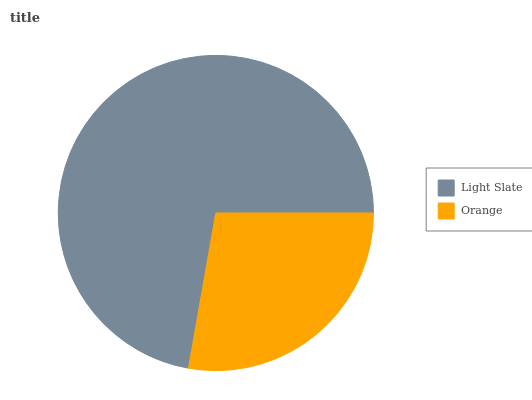Is Orange the minimum?
Answer yes or no. Yes. Is Light Slate the maximum?
Answer yes or no. Yes. Is Orange the maximum?
Answer yes or no. No. Is Light Slate greater than Orange?
Answer yes or no. Yes. Is Orange less than Light Slate?
Answer yes or no. Yes. Is Orange greater than Light Slate?
Answer yes or no. No. Is Light Slate less than Orange?
Answer yes or no. No. Is Light Slate the high median?
Answer yes or no. Yes. Is Orange the low median?
Answer yes or no. Yes. Is Orange the high median?
Answer yes or no. No. Is Light Slate the low median?
Answer yes or no. No. 